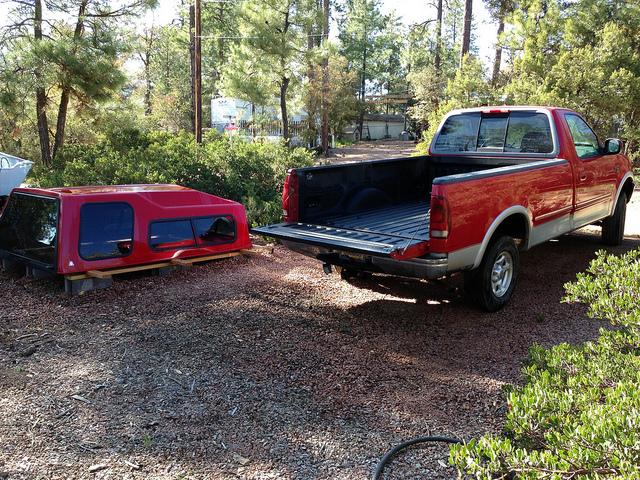What is the red thing on the ground beside the truck?
Write a very short answer. Shell. What color is the truck?
Write a very short answer. Red. Is the truck near trees?
Answer briefly. Yes. 